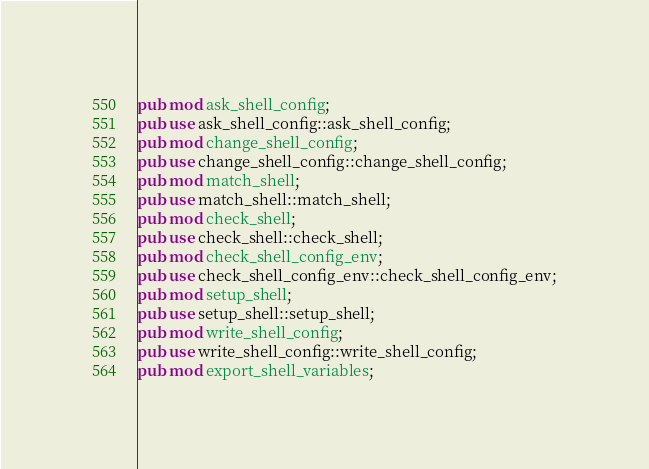Convert code to text. <code><loc_0><loc_0><loc_500><loc_500><_Rust_>pub mod ask_shell_config;
pub use ask_shell_config::ask_shell_config;
pub mod change_shell_config;
pub use change_shell_config::change_shell_config;
pub mod match_shell;
pub use match_shell::match_shell;
pub mod check_shell;
pub use check_shell::check_shell;
pub mod check_shell_config_env;
pub use check_shell_config_env::check_shell_config_env;
pub mod setup_shell;
pub use setup_shell::setup_shell;
pub mod write_shell_config;
pub use write_shell_config::write_shell_config;
pub mod export_shell_variables;</code> 